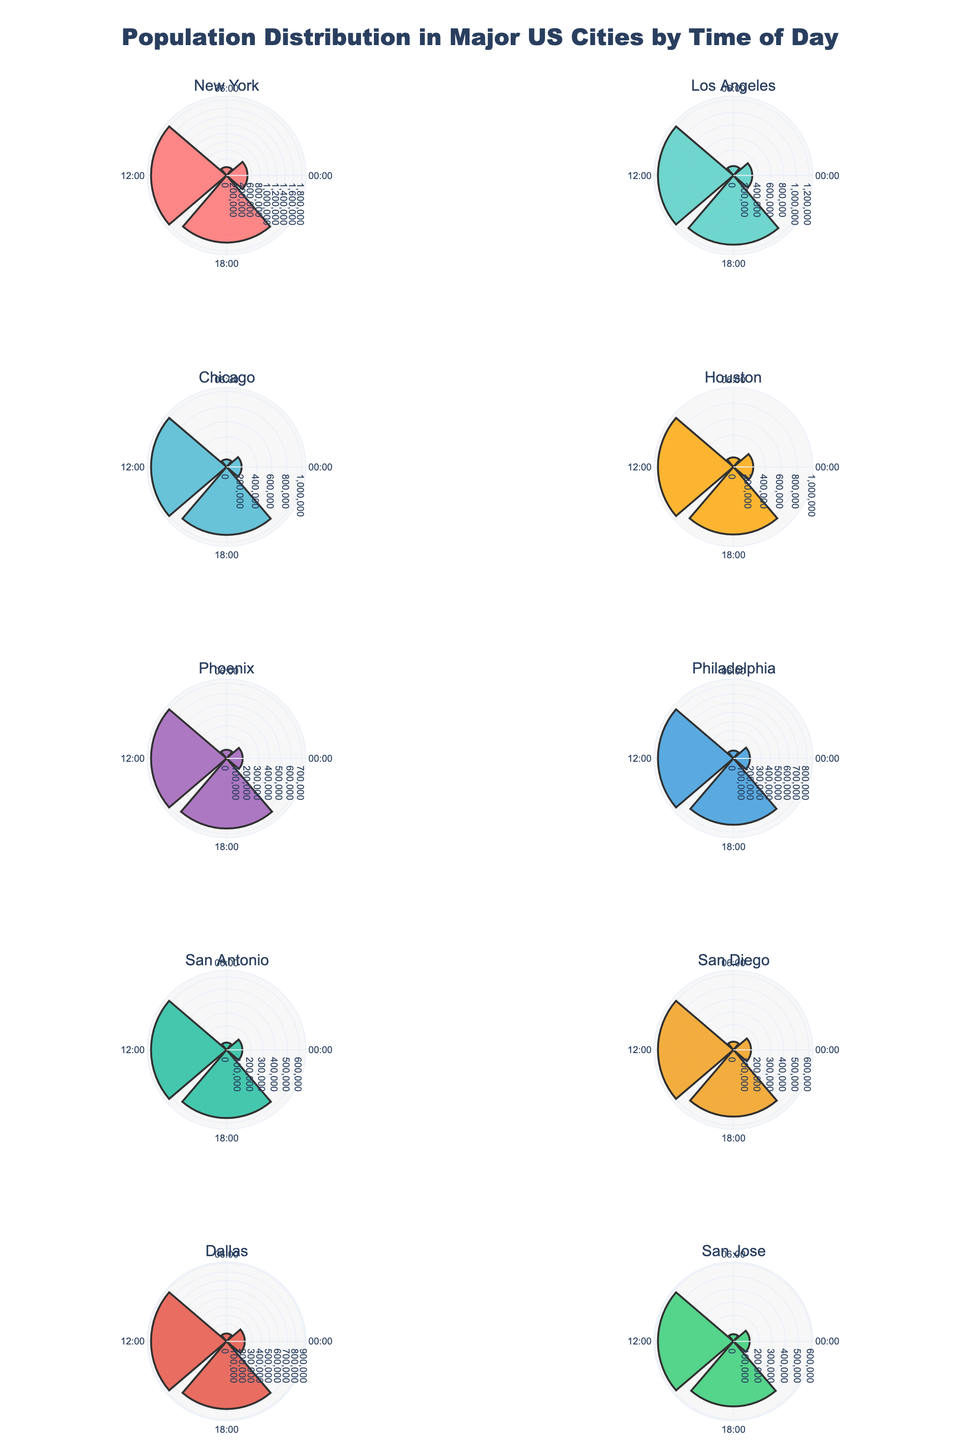What's the highest population density in New York throughout the day? The highest population density in New York can be identified by looking at the bar that extends the furthest in the subplot for New York. The time with the highest density is at 12:00 PM.
Answer: 1,800,000 How does the population density at 18:00 in Los Angeles compare to Chicago? To compare the population densities, observe the bars for 18:00 in both Los Angeles and Chicago subplots. Los Angeles has a slightly higher population density than Chicago at 18:00.
Answer: Los Angeles is higher Which city has the lowest population density at 06:00? Look at the segments for 06:00 in all subplots and find which one is the shortest. San Jose has the lowest population density at 06:00.
Answer: San Jose What's the average population density at 00:00 across all cities? Add the population densities of all cities at 00:00 and divide by the number of cities. (500,000 + 300,000 + 200,000 + 250,000 + 150,000 + 180,000 + 130,000 + 140,000 + 210,000 + 125,000)/10 = 2,185,000/10
Answer: 218,500 How does the population density pattern in San Diego change throughout the day? By looking at the lengths of the bars in the San Diego subplot, it's visible that the population starts at 140,000 at 00:00, dips to 65,000 at 06:00, rises to 600,000 at 12:00, and then decreases to 530,000 at 18:00.
Answer: Decrease at 06:00, peaks at 12:00 Which city has the most evenly distributed population density throughout the day? Look for the city with the most consistent bar lengths across the four times of day. San Antonio has relatively similar population densities throughout the day.
Answer: San Antonio What’s the total population density recorded at 12:00 across all cities? Sum the population densities of all cities at 12:00. (1,800,000 + 1,200,000 + 1,000,000 + 950,000 + 700,000 + 820,000 + 620,000 + 600,000 + 870,000 + 580,000) = 9,140,000
Answer: 9,140,000 At which time of day is Chicago's population density the highest? Identify the longest bar in the Chicago subplot, which is at 12:00 with a population density of 1,000,000.
Answer: 12:00 Compare the population densities of New York and San Francisco at 06:00. Observe the bars for 06:00 in the subplots for New York and San Francisco. New York has a higher population density than San Francisco at 06:00.
Answer: New York is higher 